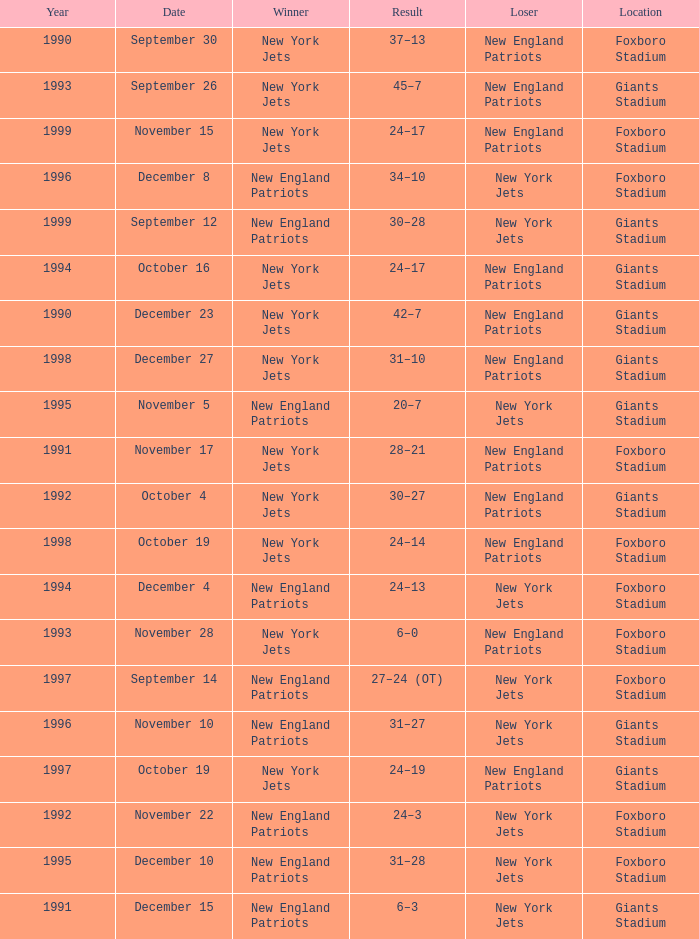Would you be able to parse every entry in this table? {'header': ['Year', 'Date', 'Winner', 'Result', 'Loser', 'Location'], 'rows': [['1990', 'September 30', 'New York Jets', '37–13', 'New England Patriots', 'Foxboro Stadium'], ['1993', 'September 26', 'New York Jets', '45–7', 'New England Patriots', 'Giants Stadium'], ['1999', 'November 15', 'New York Jets', '24–17', 'New England Patriots', 'Foxboro Stadium'], ['1996', 'December 8', 'New England Patriots', '34–10', 'New York Jets', 'Foxboro Stadium'], ['1999', 'September 12', 'New England Patriots', '30–28', 'New York Jets', 'Giants Stadium'], ['1994', 'October 16', 'New York Jets', '24–17', 'New England Patriots', 'Giants Stadium'], ['1990', 'December 23', 'New York Jets', '42–7', 'New England Patriots', 'Giants Stadium'], ['1998', 'December 27', 'New York Jets', '31–10', 'New England Patriots', 'Giants Stadium'], ['1995', 'November 5', 'New England Patriots', '20–7', 'New York Jets', 'Giants Stadium'], ['1991', 'November 17', 'New York Jets', '28–21', 'New England Patriots', 'Foxboro Stadium'], ['1992', 'October 4', 'New York Jets', '30–27', 'New England Patriots', 'Giants Stadium'], ['1998', 'October 19', 'New York Jets', '24–14', 'New England Patriots', 'Foxboro Stadium'], ['1994', 'December 4', 'New England Patriots', '24–13', 'New York Jets', 'Foxboro Stadium'], ['1993', 'November 28', 'New York Jets', '6–0', 'New England Patriots', 'Foxboro Stadium'], ['1997', 'September 14', 'New England Patriots', '27–24 (OT)', 'New York Jets', 'Foxboro Stadium'], ['1996', 'November 10', 'New England Patriots', '31–27', 'New York Jets', 'Giants Stadium'], ['1997', 'October 19', 'New York Jets', '24–19', 'New England Patriots', 'Giants Stadium'], ['1992', 'November 22', 'New England Patriots', '24–3', 'New York Jets', 'Foxboro Stadium'], ['1995', 'December 10', 'New England Patriots', '31–28', 'New York Jets', 'Foxboro Stadium'], ['1991', 'December 15', 'New England Patriots', '6–3', 'New York Jets', 'Giants Stadium']]} What is the location when the new york jets lost earlier than 1997 and a Result of 31–28? Foxboro Stadium. 